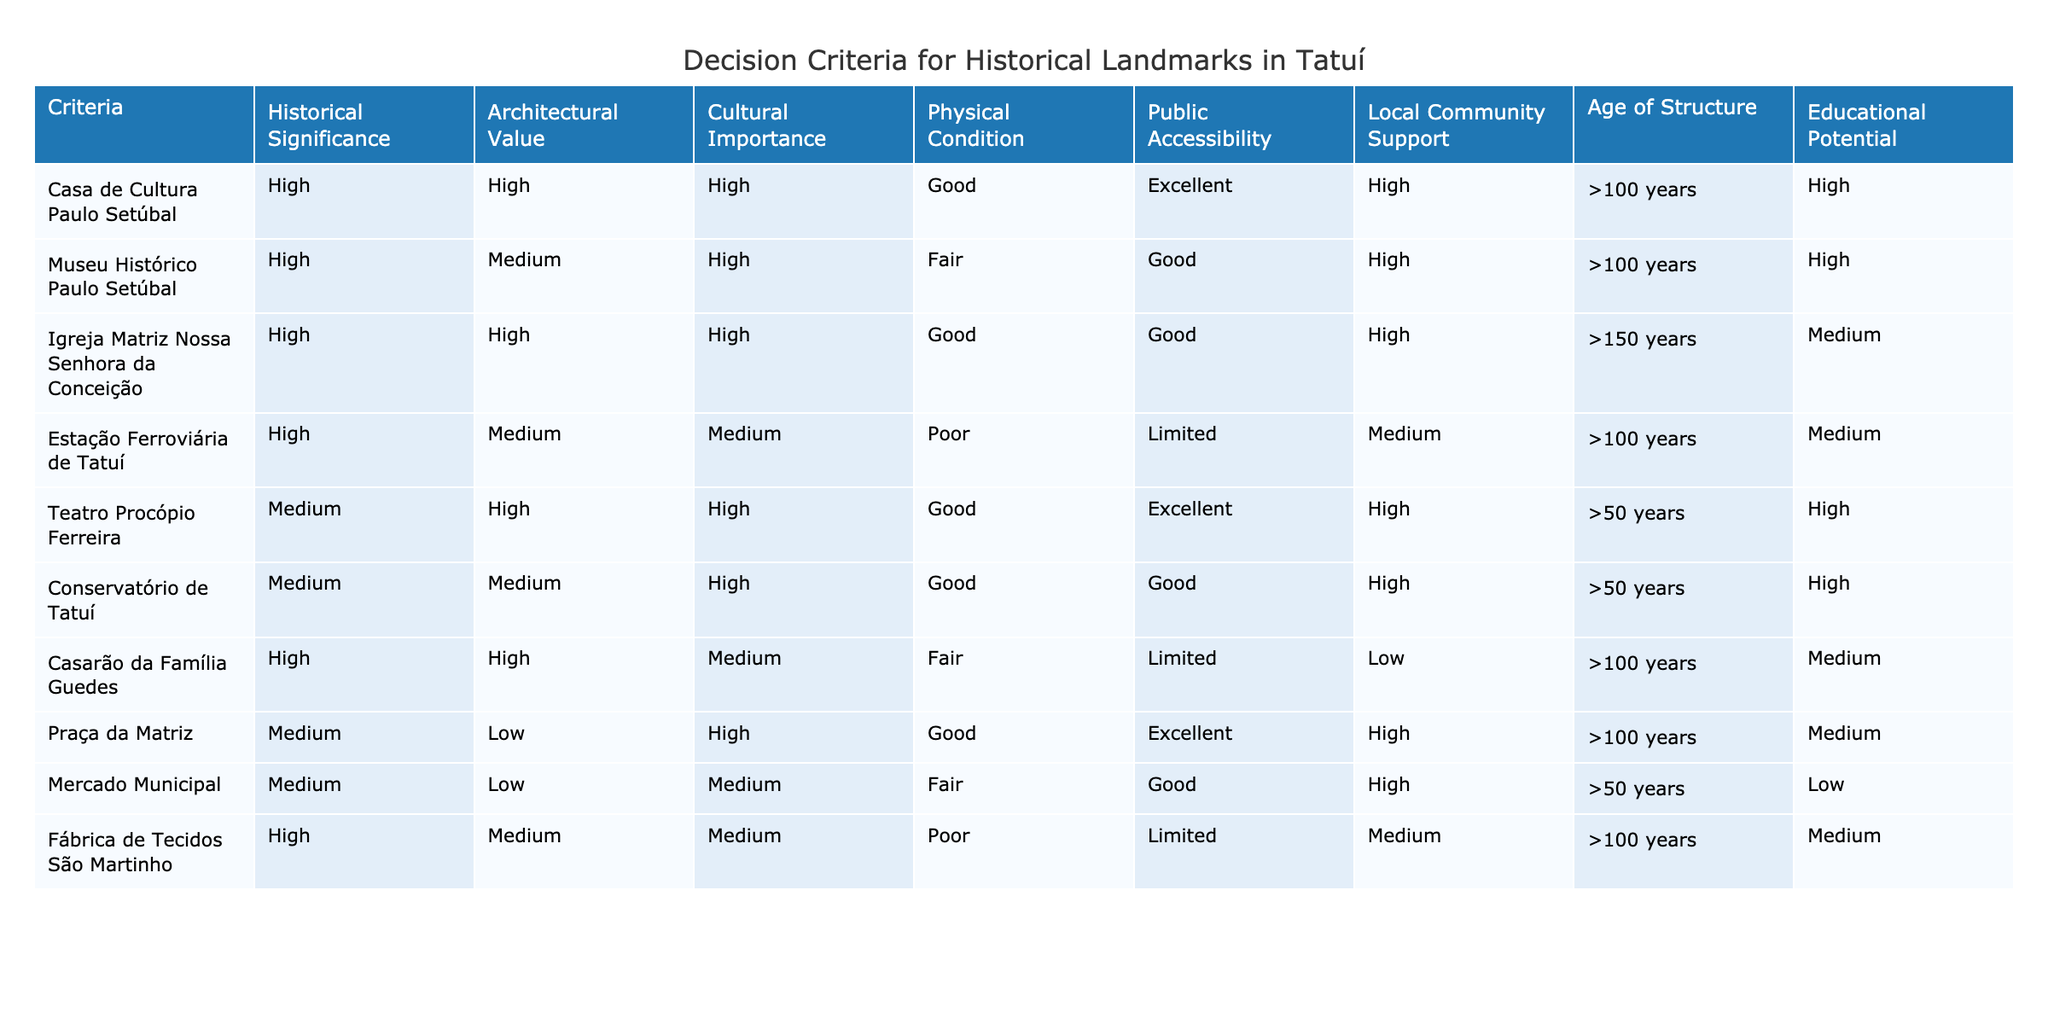What is the architectural value of the Igreja Matriz Nossa Senhora da Conceição? According to the table, the architectural value of the Igreja Matriz Nossa Senhora da Conceição is categorized as High.
Answer: High Which structure has the highest age? The age of the structures is categorized as greater than 150 years for the Igreja Matriz Nossa Senhora da Conceição, which is the highest in the table.
Answer: Igreja Matriz Nossa Senhora da Conceição How many landmarks have a physical condition listed as Poor? By filtering the table, there are two landmarks with a physical condition of Poor: Estação Ferroviária de Tatuí and Fábrica de Tecidos São Martinho. Thus, there are a total of 2 landmarks.
Answer: 2 Is the Casa de Cultura Paulo Setúbal publicly accessible? The table indicates that the public accessibility of Casa de Cultura Paulo Setúbal is categorized as Excellent, indicating it is publicly accessible.
Answer: Yes What is the educational potential of the landmark with the lowest local community support? The landmark with the lowest local community support is Casarão da Família Guedes, which has an educational potential categorized as Medium according to the table.
Answer: Medium What is the average architectural value of the landmarks categorized as Medium? From the table, there are three landmarks with architectural values categorized as Medium: Teatro Procópio Ferreira (High), Conservatório de Tatuí (Medium), and Mercado Municipal (Low). We assign numerical values, High = 3, Medium = 2, Low = 1. Calculation: (3 + 2 + 1) / 3 = 2. Thus, the average architectural value is Medium.
Answer: Medium Which landmark has the best public accessibility and how does it rank for cultural importance? Casa de Cultura Paulo Setúbal has the best public accessibility status categorized as Excellent and it is rated High for cultural importance, making it a standout landmark in both categories.
Answer: Excellent, High Does the Praça da Matriz have a high architectural value? According to the table, the architectural value of Praça da Matriz is categorized as Low, indicating it does not have a high architectural value.
Answer: No 